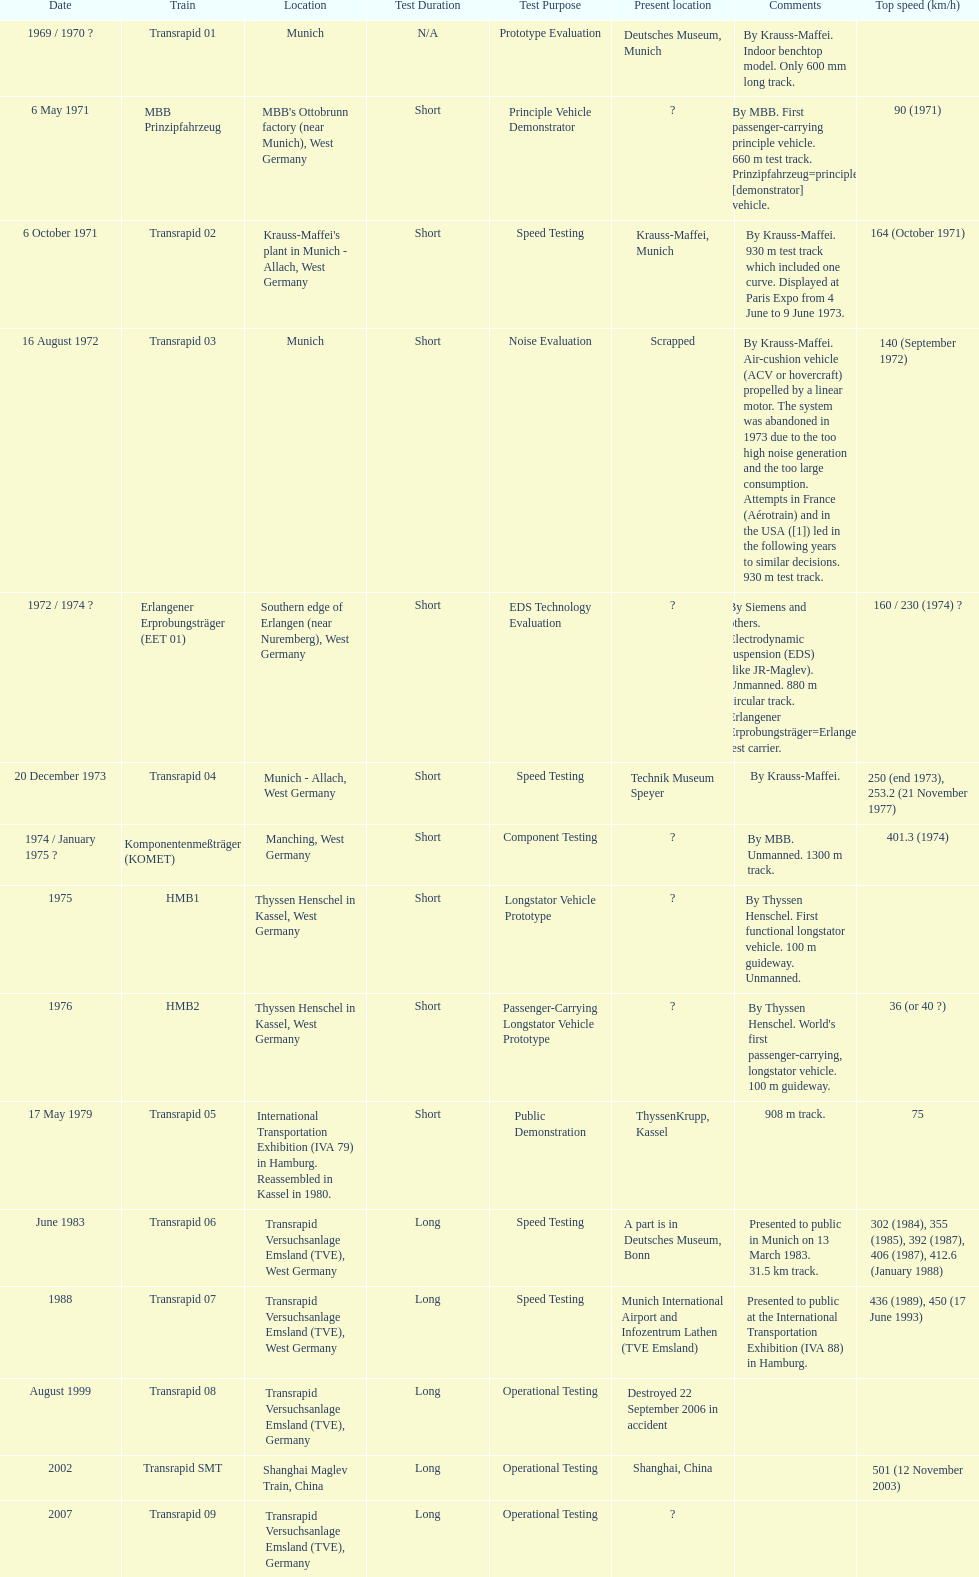What train was developed after the erlangener erprobungstrager? Transrapid 04. 